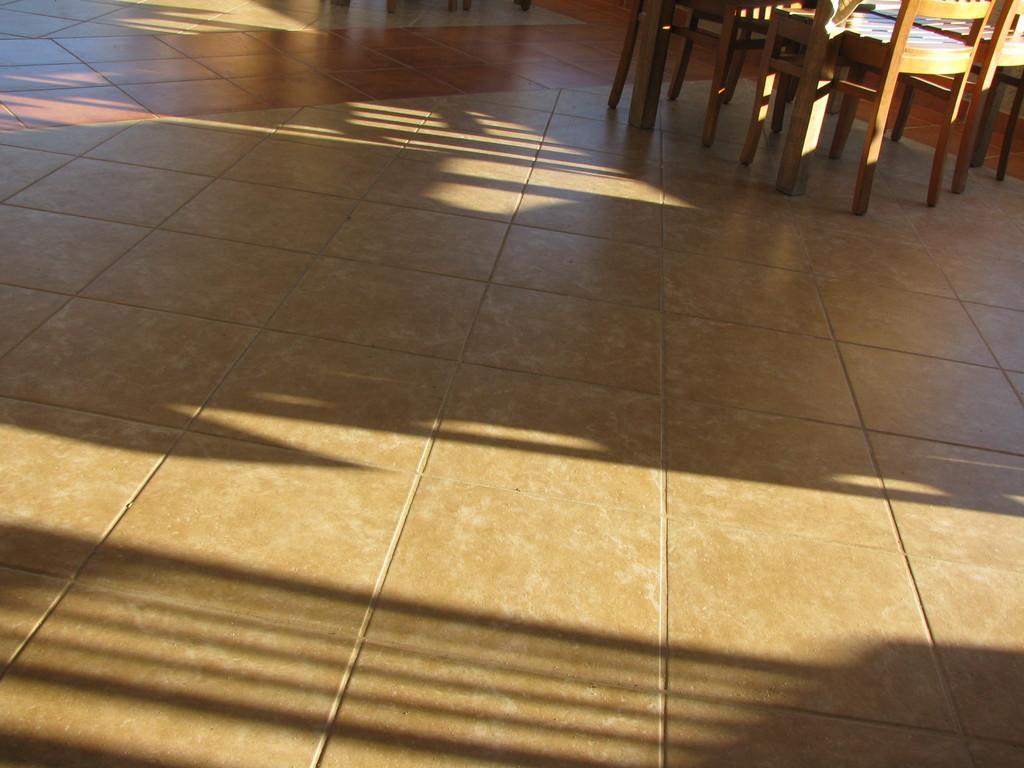Describe this image in one or two sentences. In this picture we can see a floor is covered with tiles and on the floor there are wooden chairs. 